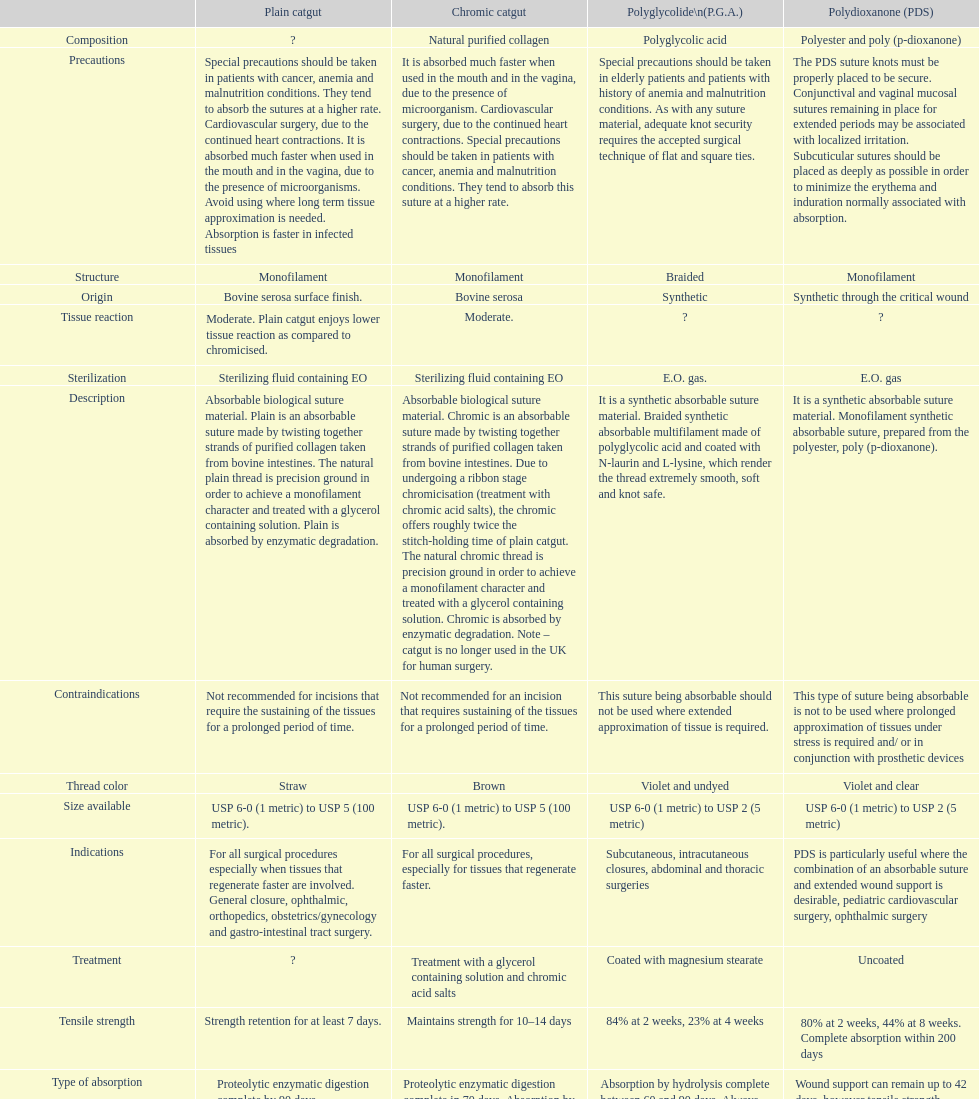What is the total number of suture materials that have a mono-filament structure? 3. 